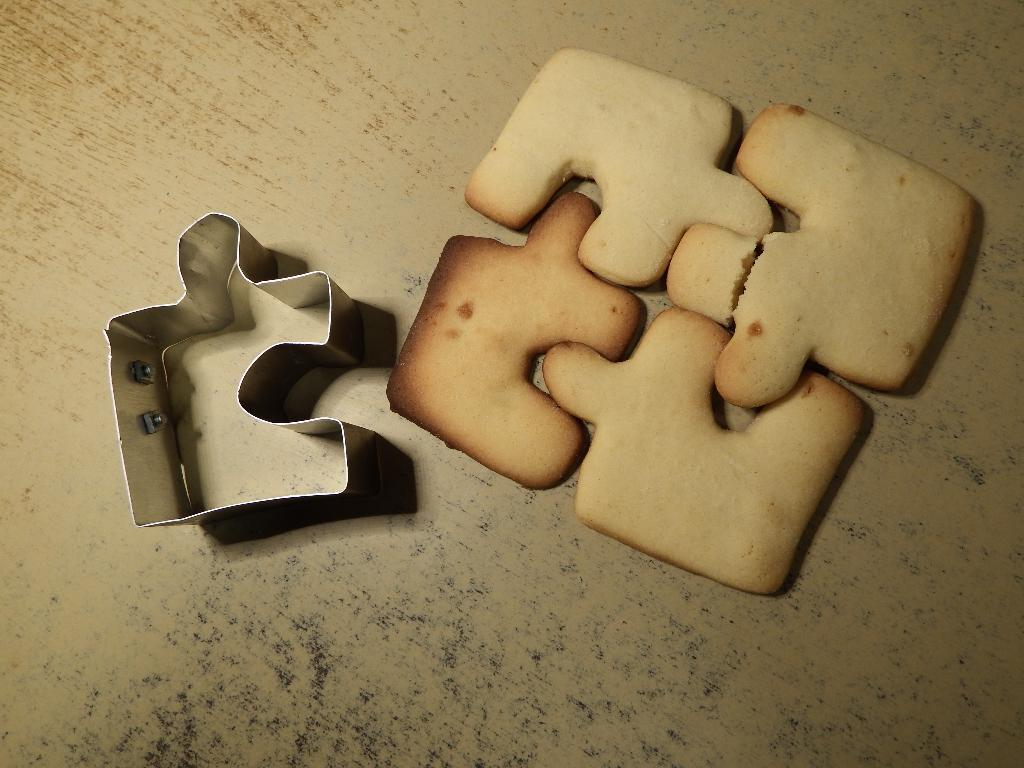How many cookies are visible in the image? There are four cookies in the image. What else can be seen on the table in the image? There is a metal shaper on the table in the image. How many friends are sitting on the cookies in the image? There are no friends sitting on the cookies in the image, as the cookies are inanimate objects and cannot support people. 